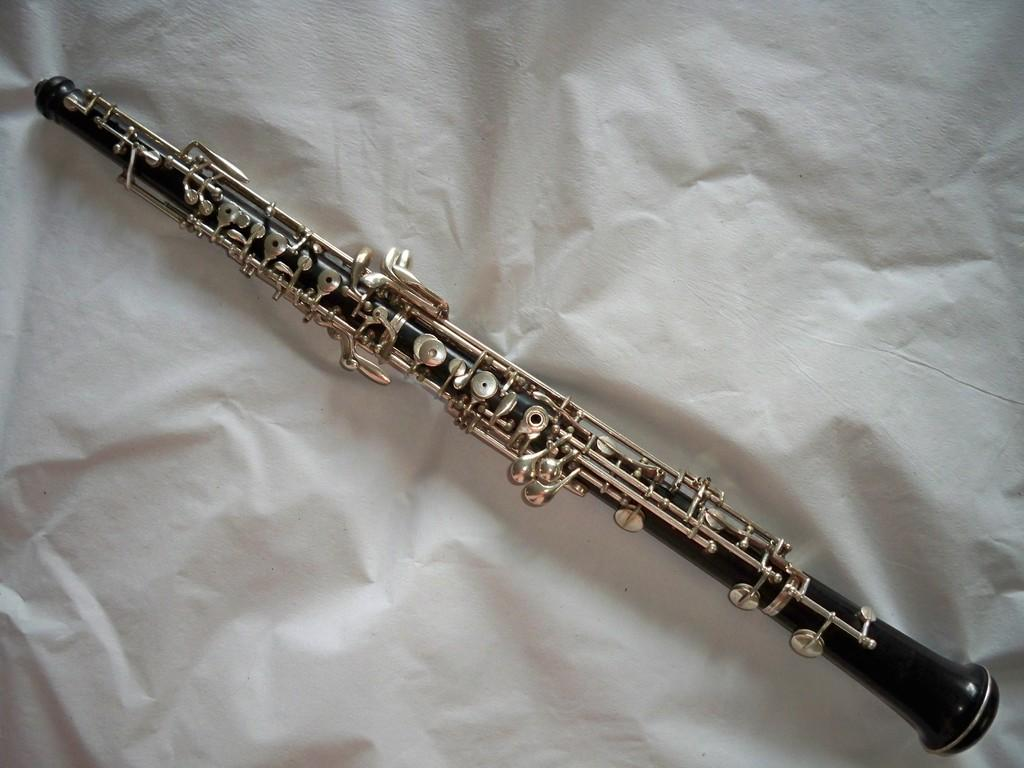What musical instrument is featured in the image? There is a piccolo clarinetto clarinet in the image. What color is the background of the image? The background of the image is white. How many fangs can be seen on the piccolo clarinet in the image? There are no fangs present on the piccolo clarinet in the image, as it is a musical instrument and not an animal. 